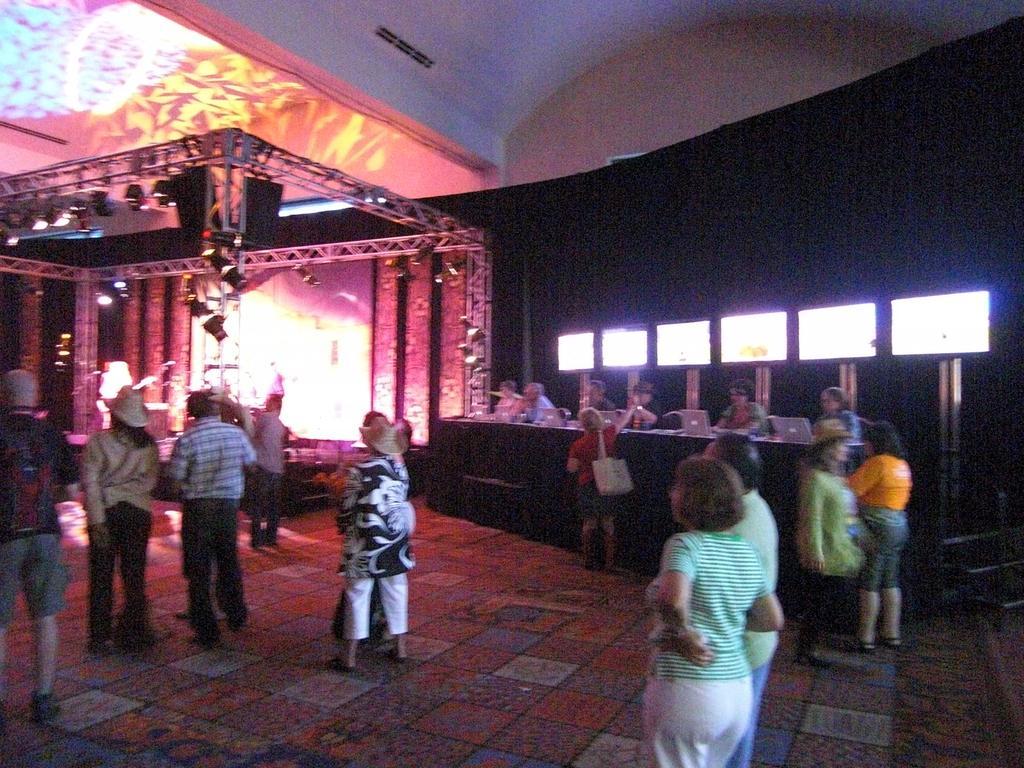Could you give a brief overview of what you see in this image? In this image I can see the group of people standing and wearing the different color dresses. I can see few people are wearing the bags and hats. In the back I can see few people in-front of the table. On the table I can see the laptops. In the back I can see the stage with lights. 